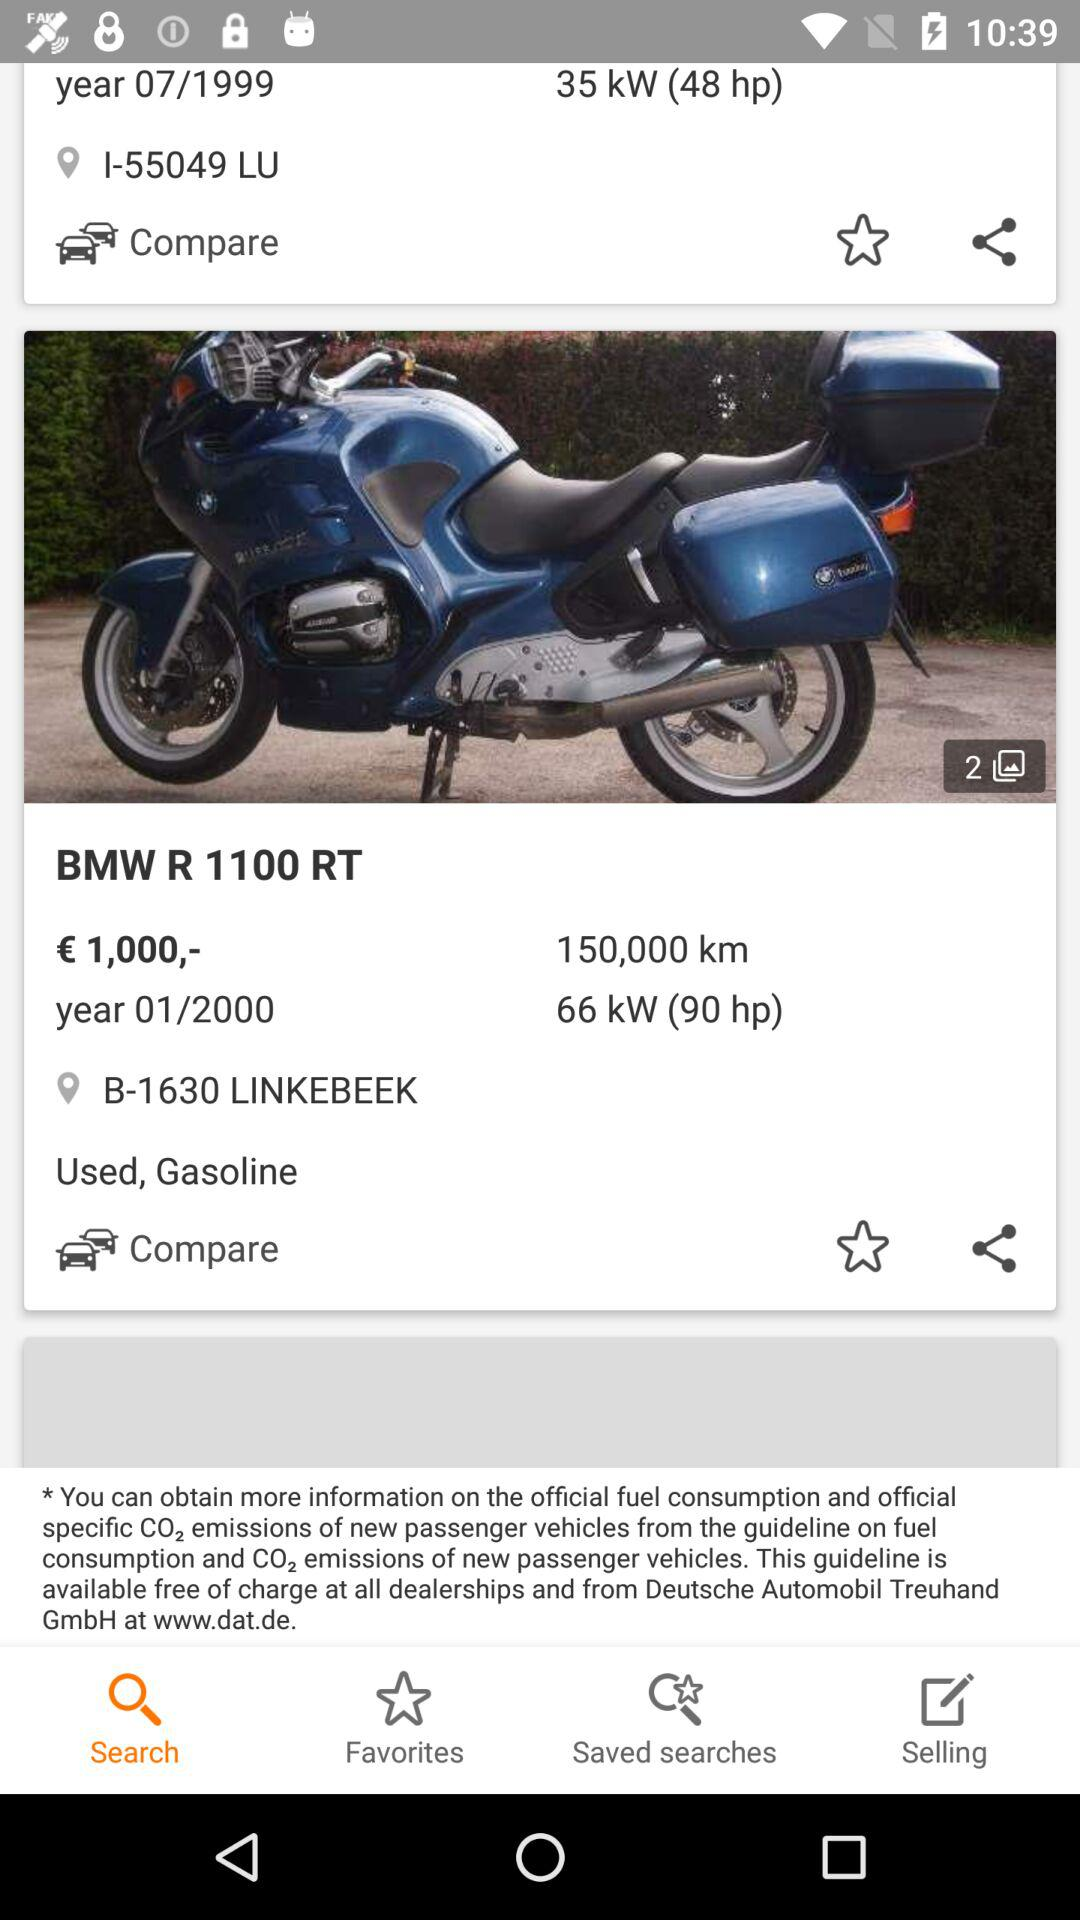What type of fuel is used by the "BMW R 1100 RT"? The type of fuel used by the "BMW R 1100 RT" is gasoline. 